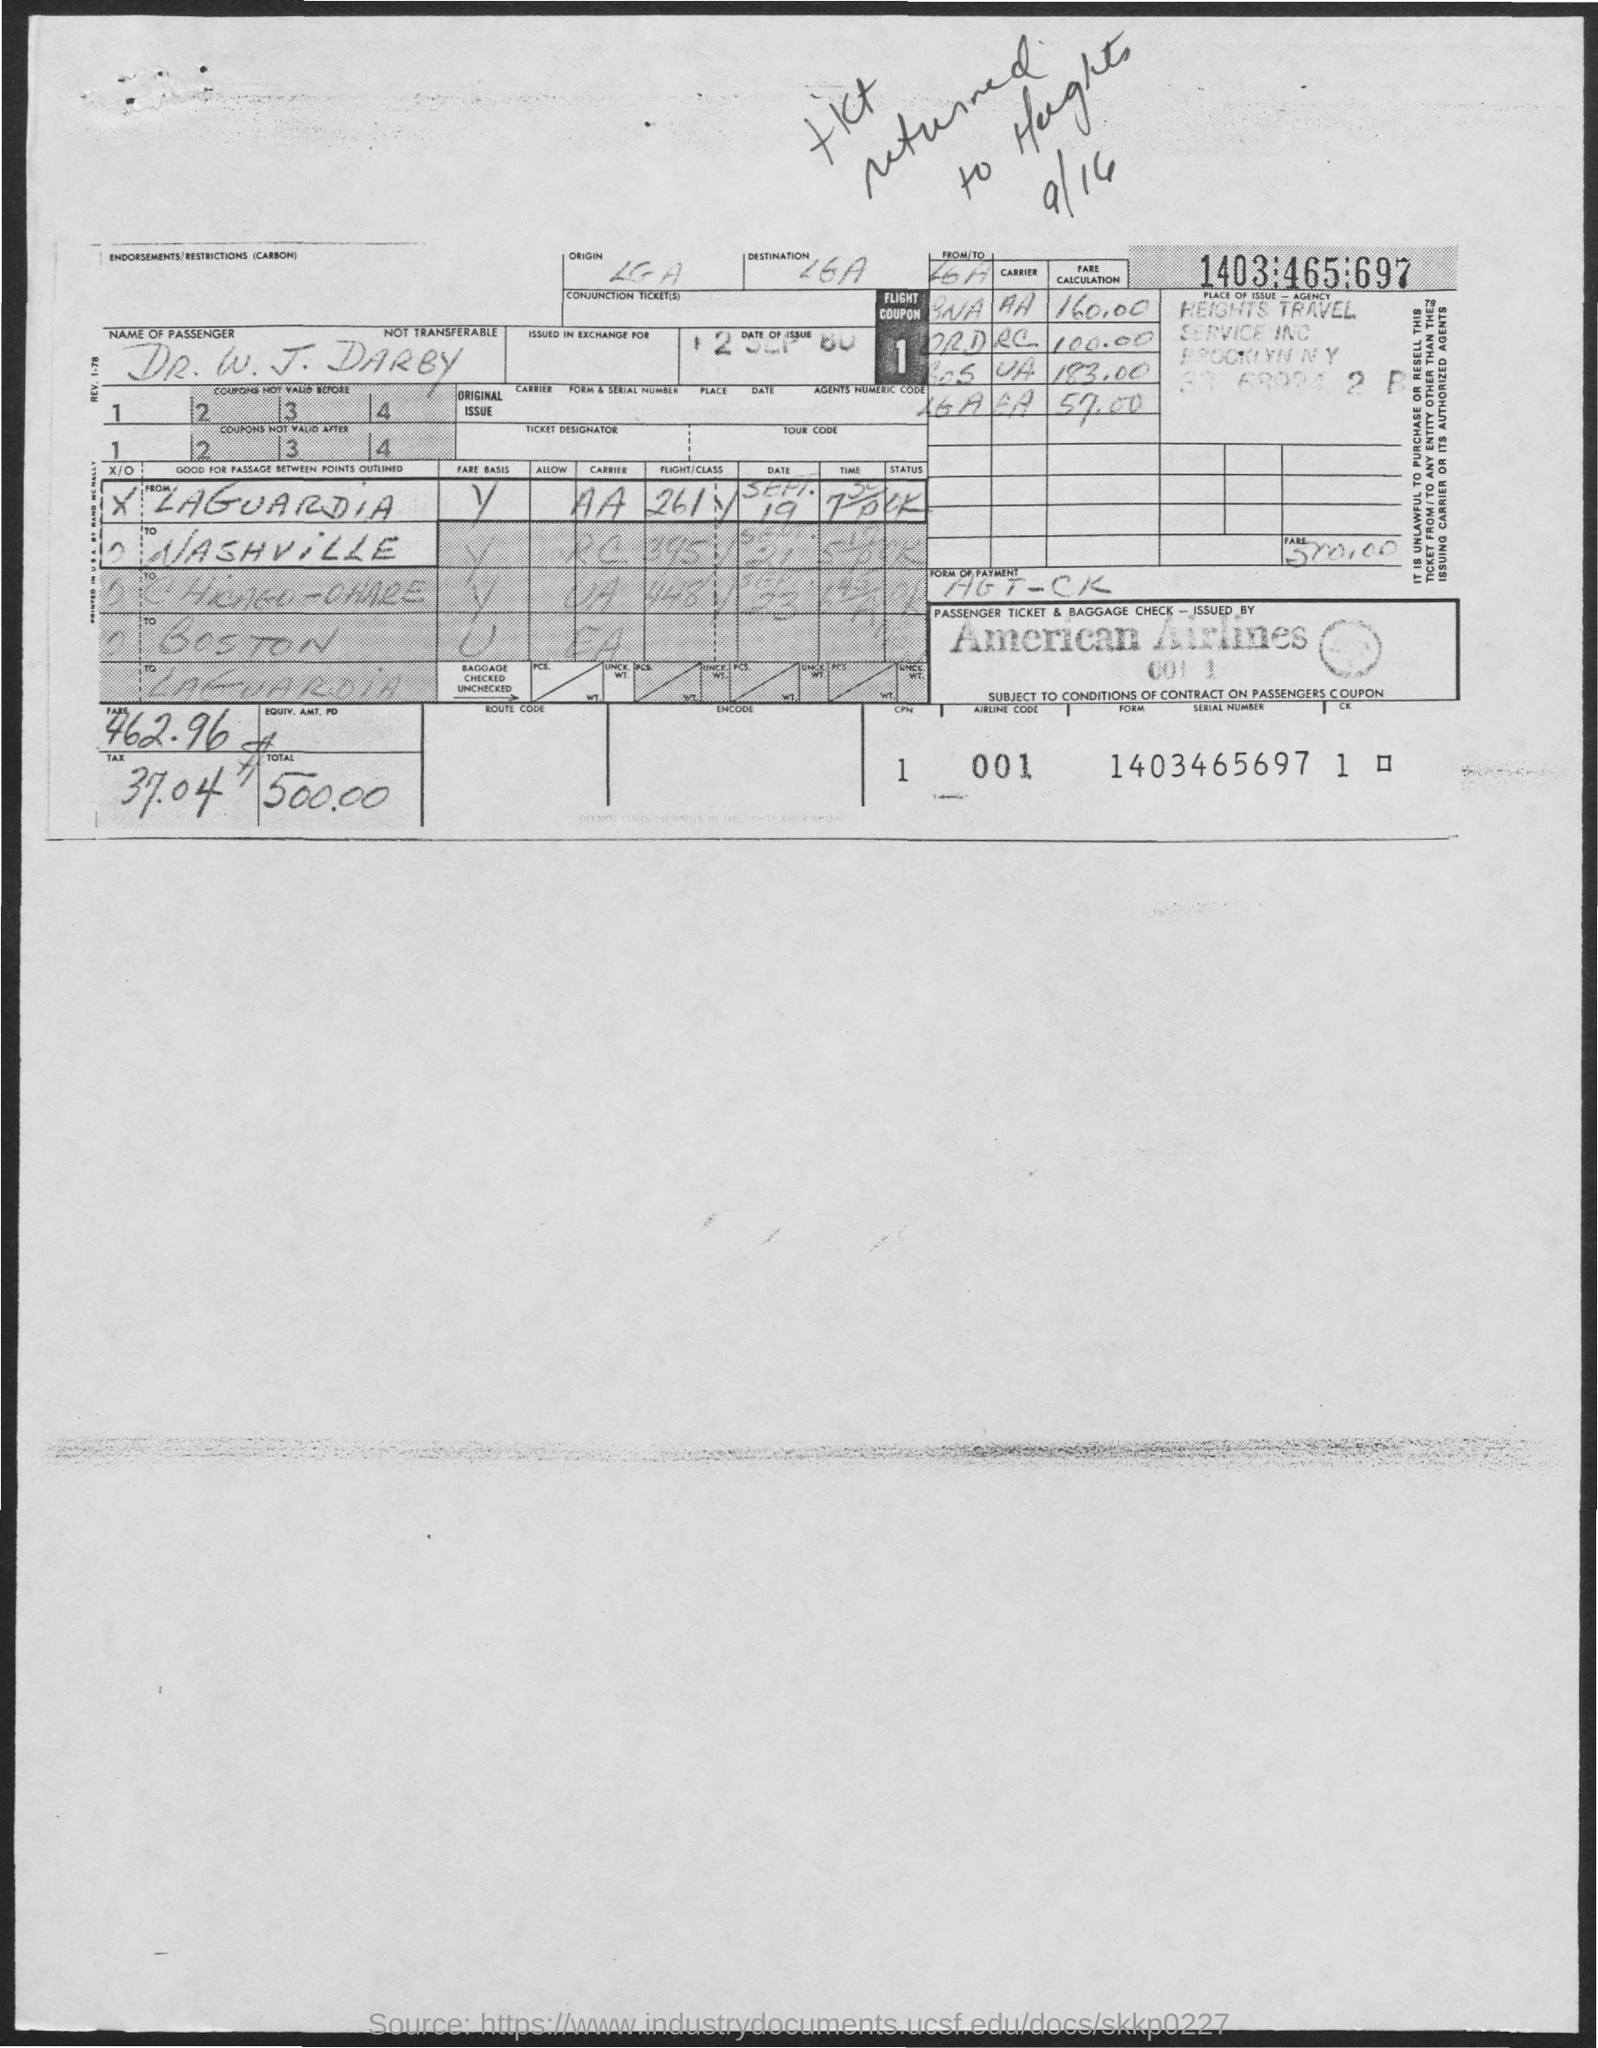How much is the total amount?
Provide a succinct answer. 500.00. How much is the tax amount?
Your response must be concise. 37.04. What is the name of passenger?
Your answer should be compact. Dr. W. J. Darby. What is the airline code?
Provide a succinct answer. 001. 